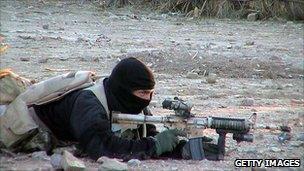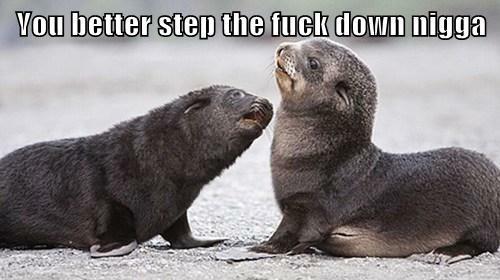The first image is the image on the left, the second image is the image on the right. For the images shown, is this caption "The right image contains two seals." true? Answer yes or no. Yes. 